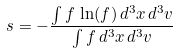<formula> <loc_0><loc_0><loc_500><loc_500>s = - \frac { \int f \, \ln ( f ) \, d ^ { 3 } x \, d ^ { 3 } v } { \int f \, d ^ { 3 } x \, d ^ { 3 } v }</formula> 